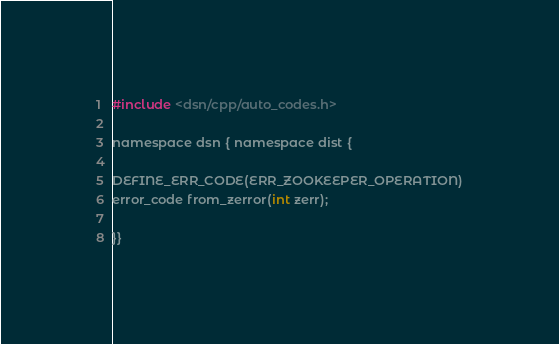<code> <loc_0><loc_0><loc_500><loc_500><_C_>#include <dsn/cpp/auto_codes.h>

namespace dsn { namespace dist {

DEFINE_ERR_CODE(ERR_ZOOKEEPER_OPERATION)
error_code from_zerror(int zerr);

}}
</code> 